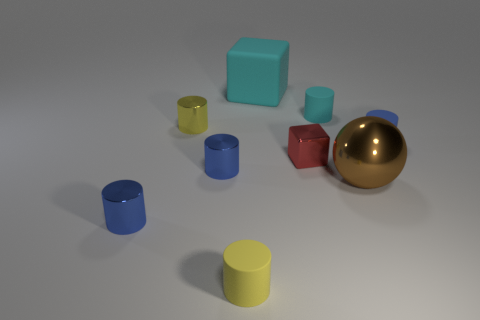The other rubber thing that is the same color as the big matte object is what size?
Make the answer very short. Small. What number of things are either blue cylinders or small things that are on the right side of the brown ball?
Keep it short and to the point. 3. There is a sphere that is the same material as the red block; what is its size?
Ensure brevity in your answer.  Large. What is the shape of the big object that is in front of the blue thing that is on the right side of the cyan block?
Your answer should be compact. Sphere. How many blue objects are either metal cylinders or matte cylinders?
Offer a terse response. 3. Are there any cyan rubber objects that are in front of the rubber object in front of the small rubber object that is on the right side of the large metal object?
Provide a short and direct response. No. How many big things are either brown metallic objects or red blocks?
Provide a succinct answer. 1. Does the rubber thing that is on the right side of the sphere have the same shape as the brown shiny object?
Provide a succinct answer. No. Is the number of tiny red metal spheres less than the number of tiny rubber cylinders?
Offer a terse response. Yes. Is there anything else of the same color as the metallic cube?
Offer a very short reply. No. 